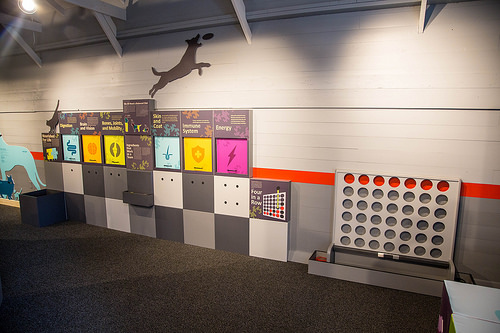<image>
Is the cat under the dog? No. The cat is not positioned under the dog. The vertical relationship between these objects is different. Where is the dog in relation to the wall? Is it above the wall? No. The dog is not positioned above the wall. The vertical arrangement shows a different relationship. 